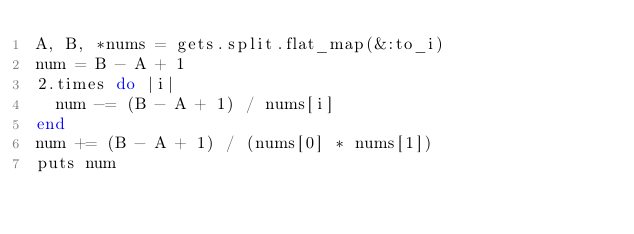Convert code to text. <code><loc_0><loc_0><loc_500><loc_500><_Ruby_>A, B, *nums = gets.split.flat_map(&:to_i)
num = B - A + 1
2.times do |i|
  num -= (B - A + 1) / nums[i]
end
num += (B - A + 1) / (nums[0] * nums[1])
puts num</code> 